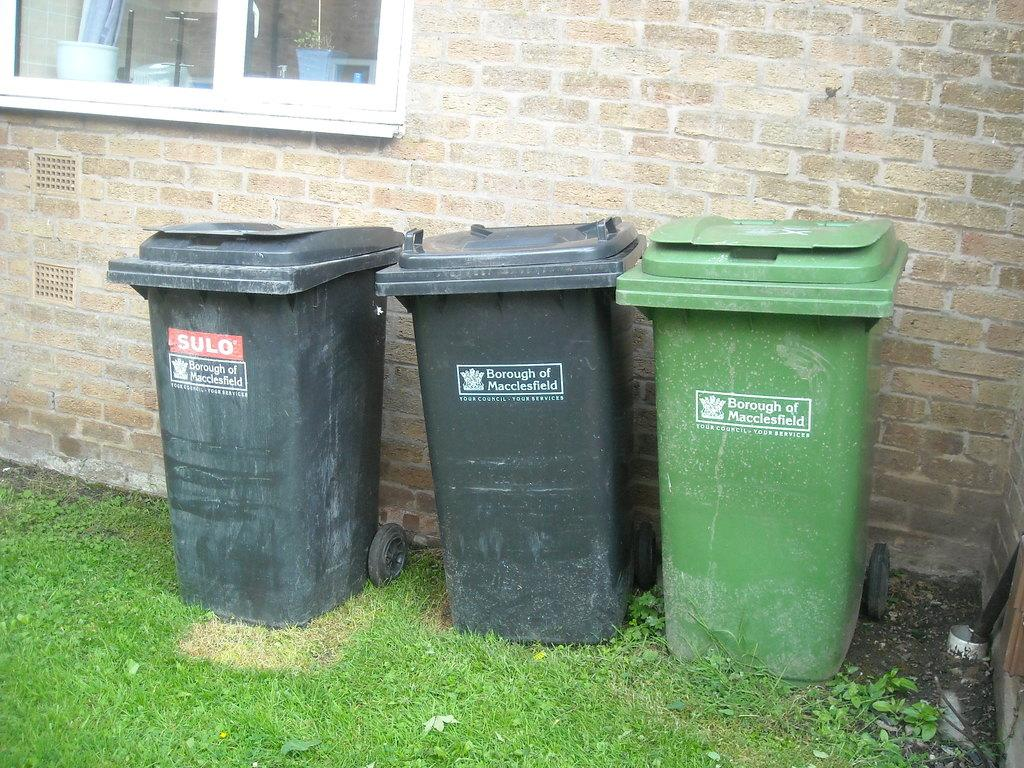<image>
Provide a brief description of the given image. Three trash bins, all are marked Borough of Macclesfield. 